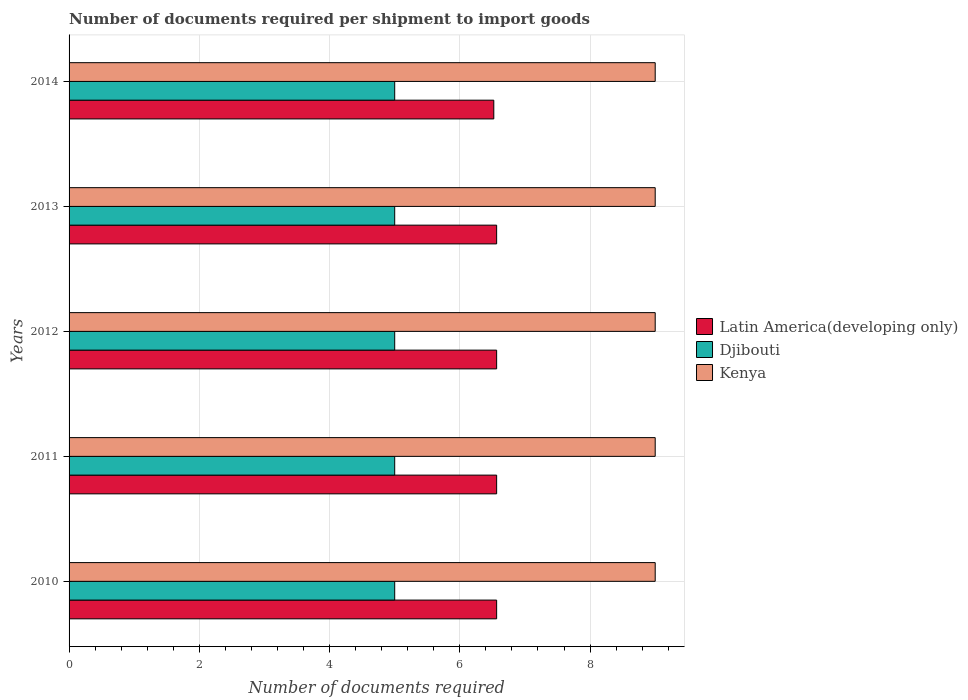How many different coloured bars are there?
Your response must be concise. 3. How many groups of bars are there?
Your answer should be very brief. 5. Are the number of bars per tick equal to the number of legend labels?
Your answer should be very brief. Yes. Are the number of bars on each tick of the Y-axis equal?
Provide a succinct answer. Yes. What is the label of the 2nd group of bars from the top?
Provide a short and direct response. 2013. What is the number of documents required per shipment to import goods in Djibouti in 2014?
Provide a succinct answer. 5. Across all years, what is the maximum number of documents required per shipment to import goods in Djibouti?
Offer a very short reply. 5. Across all years, what is the minimum number of documents required per shipment to import goods in Kenya?
Keep it short and to the point. 9. In which year was the number of documents required per shipment to import goods in Djibouti maximum?
Ensure brevity in your answer.  2010. In which year was the number of documents required per shipment to import goods in Latin America(developing only) minimum?
Provide a succinct answer. 2014. What is the total number of documents required per shipment to import goods in Latin America(developing only) in the graph?
Keep it short and to the point. 32.78. What is the difference between the number of documents required per shipment to import goods in Djibouti in 2011 and the number of documents required per shipment to import goods in Kenya in 2013?
Keep it short and to the point. -4. What is the average number of documents required per shipment to import goods in Kenya per year?
Provide a succinct answer. 9. In the year 2013, what is the difference between the number of documents required per shipment to import goods in Latin America(developing only) and number of documents required per shipment to import goods in Kenya?
Give a very brief answer. -2.43. In how many years, is the number of documents required per shipment to import goods in Djibouti greater than 4.8 ?
Your response must be concise. 5. What is the ratio of the number of documents required per shipment to import goods in Latin America(developing only) in 2013 to that in 2014?
Make the answer very short. 1.01. Is the number of documents required per shipment to import goods in Djibouti in 2010 less than that in 2012?
Give a very brief answer. No. Is the difference between the number of documents required per shipment to import goods in Latin America(developing only) in 2010 and 2011 greater than the difference between the number of documents required per shipment to import goods in Kenya in 2010 and 2011?
Make the answer very short. No. What is the difference between the highest and the second highest number of documents required per shipment to import goods in Kenya?
Your answer should be compact. 0. What is the difference between the highest and the lowest number of documents required per shipment to import goods in Latin America(developing only)?
Provide a succinct answer. 0.04. What does the 3rd bar from the top in 2014 represents?
Your answer should be very brief. Latin America(developing only). What does the 1st bar from the bottom in 2013 represents?
Offer a very short reply. Latin America(developing only). Is it the case that in every year, the sum of the number of documents required per shipment to import goods in Latin America(developing only) and number of documents required per shipment to import goods in Kenya is greater than the number of documents required per shipment to import goods in Djibouti?
Ensure brevity in your answer.  Yes. How many years are there in the graph?
Make the answer very short. 5. Does the graph contain any zero values?
Your response must be concise. No. How are the legend labels stacked?
Give a very brief answer. Vertical. What is the title of the graph?
Your answer should be very brief. Number of documents required per shipment to import goods. What is the label or title of the X-axis?
Provide a succinct answer. Number of documents required. What is the label or title of the Y-axis?
Offer a terse response. Years. What is the Number of documents required in Latin America(developing only) in 2010?
Offer a very short reply. 6.57. What is the Number of documents required in Djibouti in 2010?
Give a very brief answer. 5. What is the Number of documents required of Kenya in 2010?
Provide a short and direct response. 9. What is the Number of documents required of Latin America(developing only) in 2011?
Your response must be concise. 6.57. What is the Number of documents required in Djibouti in 2011?
Your answer should be compact. 5. What is the Number of documents required of Kenya in 2011?
Provide a short and direct response. 9. What is the Number of documents required in Latin America(developing only) in 2012?
Your answer should be very brief. 6.57. What is the Number of documents required in Kenya in 2012?
Your response must be concise. 9. What is the Number of documents required in Latin America(developing only) in 2013?
Provide a short and direct response. 6.57. What is the Number of documents required of Djibouti in 2013?
Provide a short and direct response. 5. What is the Number of documents required of Kenya in 2013?
Keep it short and to the point. 9. What is the Number of documents required of Latin America(developing only) in 2014?
Keep it short and to the point. 6.52. What is the Number of documents required of Djibouti in 2014?
Your answer should be very brief. 5. What is the Number of documents required in Kenya in 2014?
Provide a succinct answer. 9. Across all years, what is the maximum Number of documents required in Latin America(developing only)?
Offer a very short reply. 6.57. Across all years, what is the minimum Number of documents required of Latin America(developing only)?
Your response must be concise. 6.52. What is the total Number of documents required in Latin America(developing only) in the graph?
Your answer should be compact. 32.78. What is the total Number of documents required in Djibouti in the graph?
Your response must be concise. 25. What is the difference between the Number of documents required in Latin America(developing only) in 2010 and that in 2011?
Your answer should be compact. 0. What is the difference between the Number of documents required of Djibouti in 2010 and that in 2013?
Offer a terse response. 0. What is the difference between the Number of documents required in Kenya in 2010 and that in 2013?
Offer a terse response. 0. What is the difference between the Number of documents required of Latin America(developing only) in 2010 and that in 2014?
Provide a short and direct response. 0.04. What is the difference between the Number of documents required in Djibouti in 2010 and that in 2014?
Your answer should be very brief. 0. What is the difference between the Number of documents required of Kenya in 2010 and that in 2014?
Your answer should be very brief. 0. What is the difference between the Number of documents required in Latin America(developing only) in 2011 and that in 2012?
Offer a terse response. 0. What is the difference between the Number of documents required of Djibouti in 2011 and that in 2012?
Your answer should be compact. 0. What is the difference between the Number of documents required of Kenya in 2011 and that in 2012?
Make the answer very short. 0. What is the difference between the Number of documents required in Latin America(developing only) in 2011 and that in 2013?
Offer a terse response. 0. What is the difference between the Number of documents required of Djibouti in 2011 and that in 2013?
Offer a terse response. 0. What is the difference between the Number of documents required in Kenya in 2011 and that in 2013?
Ensure brevity in your answer.  0. What is the difference between the Number of documents required of Latin America(developing only) in 2011 and that in 2014?
Provide a short and direct response. 0.04. What is the difference between the Number of documents required in Latin America(developing only) in 2012 and that in 2013?
Provide a short and direct response. 0. What is the difference between the Number of documents required in Kenya in 2012 and that in 2013?
Keep it short and to the point. 0. What is the difference between the Number of documents required of Latin America(developing only) in 2012 and that in 2014?
Give a very brief answer. 0.04. What is the difference between the Number of documents required of Djibouti in 2012 and that in 2014?
Offer a terse response. 0. What is the difference between the Number of documents required in Kenya in 2012 and that in 2014?
Give a very brief answer. 0. What is the difference between the Number of documents required in Latin America(developing only) in 2013 and that in 2014?
Ensure brevity in your answer.  0.04. What is the difference between the Number of documents required in Latin America(developing only) in 2010 and the Number of documents required in Djibouti in 2011?
Your answer should be compact. 1.57. What is the difference between the Number of documents required of Latin America(developing only) in 2010 and the Number of documents required of Kenya in 2011?
Keep it short and to the point. -2.43. What is the difference between the Number of documents required in Djibouti in 2010 and the Number of documents required in Kenya in 2011?
Your answer should be very brief. -4. What is the difference between the Number of documents required in Latin America(developing only) in 2010 and the Number of documents required in Djibouti in 2012?
Offer a very short reply. 1.57. What is the difference between the Number of documents required of Latin America(developing only) in 2010 and the Number of documents required of Kenya in 2012?
Offer a terse response. -2.43. What is the difference between the Number of documents required of Latin America(developing only) in 2010 and the Number of documents required of Djibouti in 2013?
Offer a terse response. 1.57. What is the difference between the Number of documents required of Latin America(developing only) in 2010 and the Number of documents required of Kenya in 2013?
Your answer should be compact. -2.43. What is the difference between the Number of documents required in Latin America(developing only) in 2010 and the Number of documents required in Djibouti in 2014?
Your response must be concise. 1.57. What is the difference between the Number of documents required in Latin America(developing only) in 2010 and the Number of documents required in Kenya in 2014?
Ensure brevity in your answer.  -2.43. What is the difference between the Number of documents required of Djibouti in 2010 and the Number of documents required of Kenya in 2014?
Provide a short and direct response. -4. What is the difference between the Number of documents required in Latin America(developing only) in 2011 and the Number of documents required in Djibouti in 2012?
Your response must be concise. 1.57. What is the difference between the Number of documents required of Latin America(developing only) in 2011 and the Number of documents required of Kenya in 2012?
Provide a short and direct response. -2.43. What is the difference between the Number of documents required of Latin America(developing only) in 2011 and the Number of documents required of Djibouti in 2013?
Provide a short and direct response. 1.57. What is the difference between the Number of documents required of Latin America(developing only) in 2011 and the Number of documents required of Kenya in 2013?
Make the answer very short. -2.43. What is the difference between the Number of documents required of Latin America(developing only) in 2011 and the Number of documents required of Djibouti in 2014?
Provide a succinct answer. 1.57. What is the difference between the Number of documents required of Latin America(developing only) in 2011 and the Number of documents required of Kenya in 2014?
Provide a short and direct response. -2.43. What is the difference between the Number of documents required of Djibouti in 2011 and the Number of documents required of Kenya in 2014?
Keep it short and to the point. -4. What is the difference between the Number of documents required in Latin America(developing only) in 2012 and the Number of documents required in Djibouti in 2013?
Your response must be concise. 1.57. What is the difference between the Number of documents required in Latin America(developing only) in 2012 and the Number of documents required in Kenya in 2013?
Give a very brief answer. -2.43. What is the difference between the Number of documents required in Djibouti in 2012 and the Number of documents required in Kenya in 2013?
Provide a succinct answer. -4. What is the difference between the Number of documents required in Latin America(developing only) in 2012 and the Number of documents required in Djibouti in 2014?
Give a very brief answer. 1.57. What is the difference between the Number of documents required of Latin America(developing only) in 2012 and the Number of documents required of Kenya in 2014?
Give a very brief answer. -2.43. What is the difference between the Number of documents required in Djibouti in 2012 and the Number of documents required in Kenya in 2014?
Your answer should be very brief. -4. What is the difference between the Number of documents required of Latin America(developing only) in 2013 and the Number of documents required of Djibouti in 2014?
Your answer should be very brief. 1.57. What is the difference between the Number of documents required in Latin America(developing only) in 2013 and the Number of documents required in Kenya in 2014?
Your answer should be very brief. -2.43. What is the difference between the Number of documents required in Djibouti in 2013 and the Number of documents required in Kenya in 2014?
Keep it short and to the point. -4. What is the average Number of documents required in Latin America(developing only) per year?
Provide a short and direct response. 6.56. What is the average Number of documents required of Kenya per year?
Provide a short and direct response. 9. In the year 2010, what is the difference between the Number of documents required of Latin America(developing only) and Number of documents required of Djibouti?
Keep it short and to the point. 1.57. In the year 2010, what is the difference between the Number of documents required of Latin America(developing only) and Number of documents required of Kenya?
Your answer should be very brief. -2.43. In the year 2010, what is the difference between the Number of documents required in Djibouti and Number of documents required in Kenya?
Your answer should be compact. -4. In the year 2011, what is the difference between the Number of documents required of Latin America(developing only) and Number of documents required of Djibouti?
Keep it short and to the point. 1.57. In the year 2011, what is the difference between the Number of documents required of Latin America(developing only) and Number of documents required of Kenya?
Provide a succinct answer. -2.43. In the year 2011, what is the difference between the Number of documents required in Djibouti and Number of documents required in Kenya?
Ensure brevity in your answer.  -4. In the year 2012, what is the difference between the Number of documents required in Latin America(developing only) and Number of documents required in Djibouti?
Make the answer very short. 1.57. In the year 2012, what is the difference between the Number of documents required of Latin America(developing only) and Number of documents required of Kenya?
Ensure brevity in your answer.  -2.43. In the year 2012, what is the difference between the Number of documents required of Djibouti and Number of documents required of Kenya?
Your answer should be compact. -4. In the year 2013, what is the difference between the Number of documents required of Latin America(developing only) and Number of documents required of Djibouti?
Keep it short and to the point. 1.57. In the year 2013, what is the difference between the Number of documents required of Latin America(developing only) and Number of documents required of Kenya?
Your answer should be very brief. -2.43. In the year 2014, what is the difference between the Number of documents required of Latin America(developing only) and Number of documents required of Djibouti?
Offer a very short reply. 1.52. In the year 2014, what is the difference between the Number of documents required in Latin America(developing only) and Number of documents required in Kenya?
Ensure brevity in your answer.  -2.48. In the year 2014, what is the difference between the Number of documents required of Djibouti and Number of documents required of Kenya?
Ensure brevity in your answer.  -4. What is the ratio of the Number of documents required in Kenya in 2010 to that in 2011?
Your answer should be very brief. 1. What is the ratio of the Number of documents required in Latin America(developing only) in 2010 to that in 2012?
Give a very brief answer. 1. What is the ratio of the Number of documents required in Djibouti in 2010 to that in 2013?
Provide a succinct answer. 1. What is the ratio of the Number of documents required in Latin America(developing only) in 2010 to that in 2014?
Make the answer very short. 1.01. What is the ratio of the Number of documents required of Kenya in 2010 to that in 2014?
Your response must be concise. 1. What is the ratio of the Number of documents required of Latin America(developing only) in 2012 to that in 2013?
Make the answer very short. 1. What is the ratio of the Number of documents required of Djibouti in 2012 to that in 2013?
Your answer should be very brief. 1. What is the ratio of the Number of documents required of Latin America(developing only) in 2012 to that in 2014?
Provide a succinct answer. 1.01. What is the ratio of the Number of documents required of Kenya in 2012 to that in 2014?
Provide a short and direct response. 1. What is the ratio of the Number of documents required in Latin America(developing only) in 2013 to that in 2014?
Offer a very short reply. 1.01. What is the difference between the highest and the second highest Number of documents required in Latin America(developing only)?
Make the answer very short. 0. What is the difference between the highest and the second highest Number of documents required of Djibouti?
Provide a succinct answer. 0. What is the difference between the highest and the lowest Number of documents required in Latin America(developing only)?
Give a very brief answer. 0.04. 